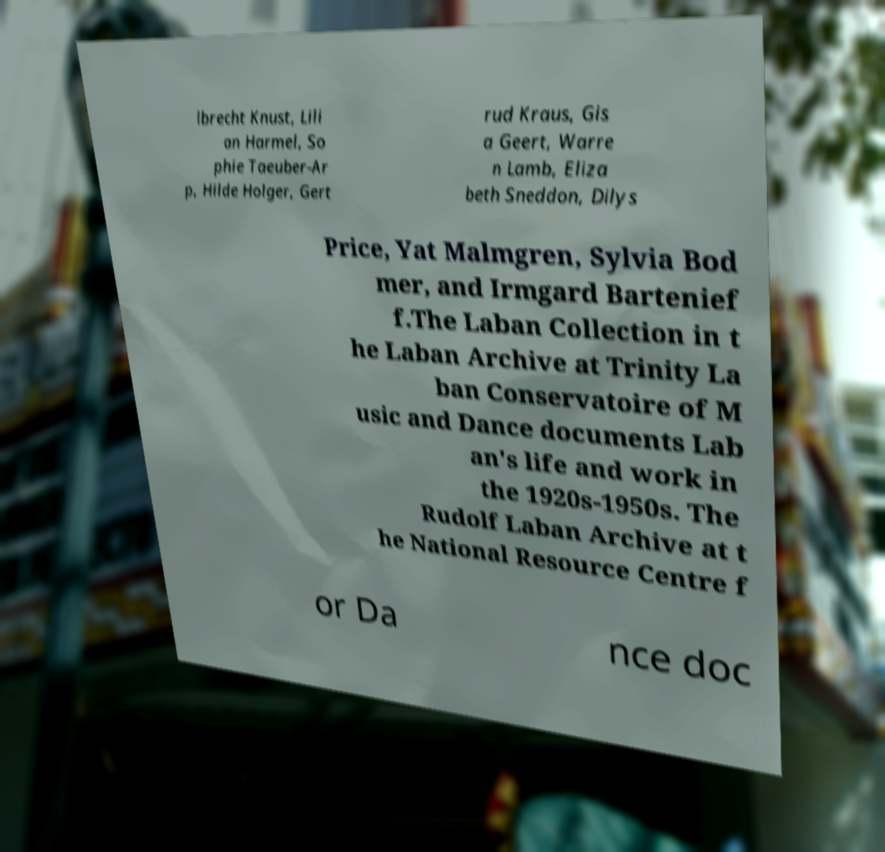Could you assist in decoding the text presented in this image and type it out clearly? lbrecht Knust, Lili an Harmel, So phie Taeuber-Ar p, Hilde Holger, Gert rud Kraus, Gis a Geert, Warre n Lamb, Eliza beth Sneddon, Dilys Price, Yat Malmgren, Sylvia Bod mer, and Irmgard Bartenief f.The Laban Collection in t he Laban Archive at Trinity La ban Conservatoire of M usic and Dance documents Lab an's life and work in the 1920s-1950s. The Rudolf Laban Archive at t he National Resource Centre f or Da nce doc 